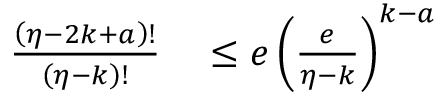<formula> <loc_0><loc_0><loc_500><loc_500>\begin{array} { r l } { \frac { \left ( \eta - 2 k + a \right ) ! } { \left ( \eta - k \right ) ! } } & \leq e \left ( \frac { e } { \eta - k } \right ) ^ { k - a } } \end{array}</formula> 